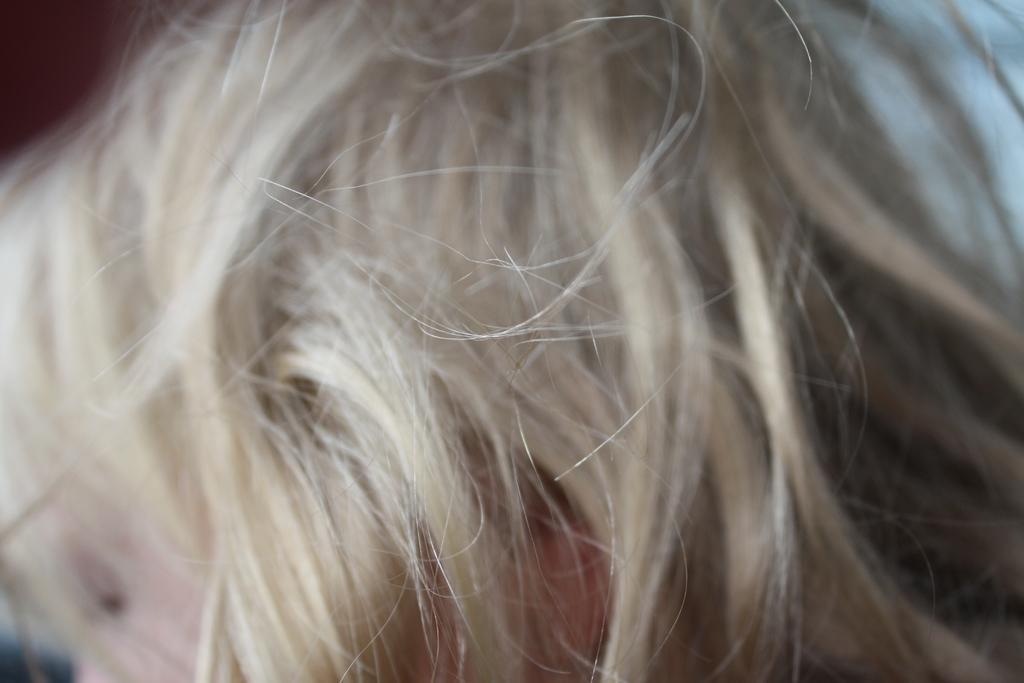How would you summarize this image in a sentence or two? In this image there is a person having hair. 